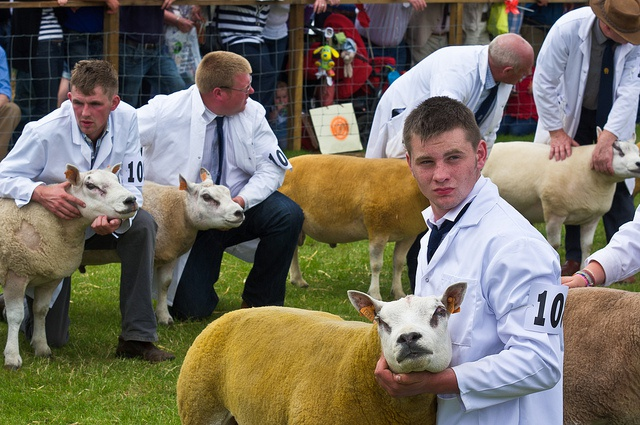Describe the objects in this image and their specific colors. I can see people in black, lavender, darkgray, brown, and gray tones, sheep in black, olive, and tan tones, people in black, lavender, and darkgray tones, people in black, lavender, darkgray, and gray tones, and people in black, darkgray, and lavender tones in this image. 